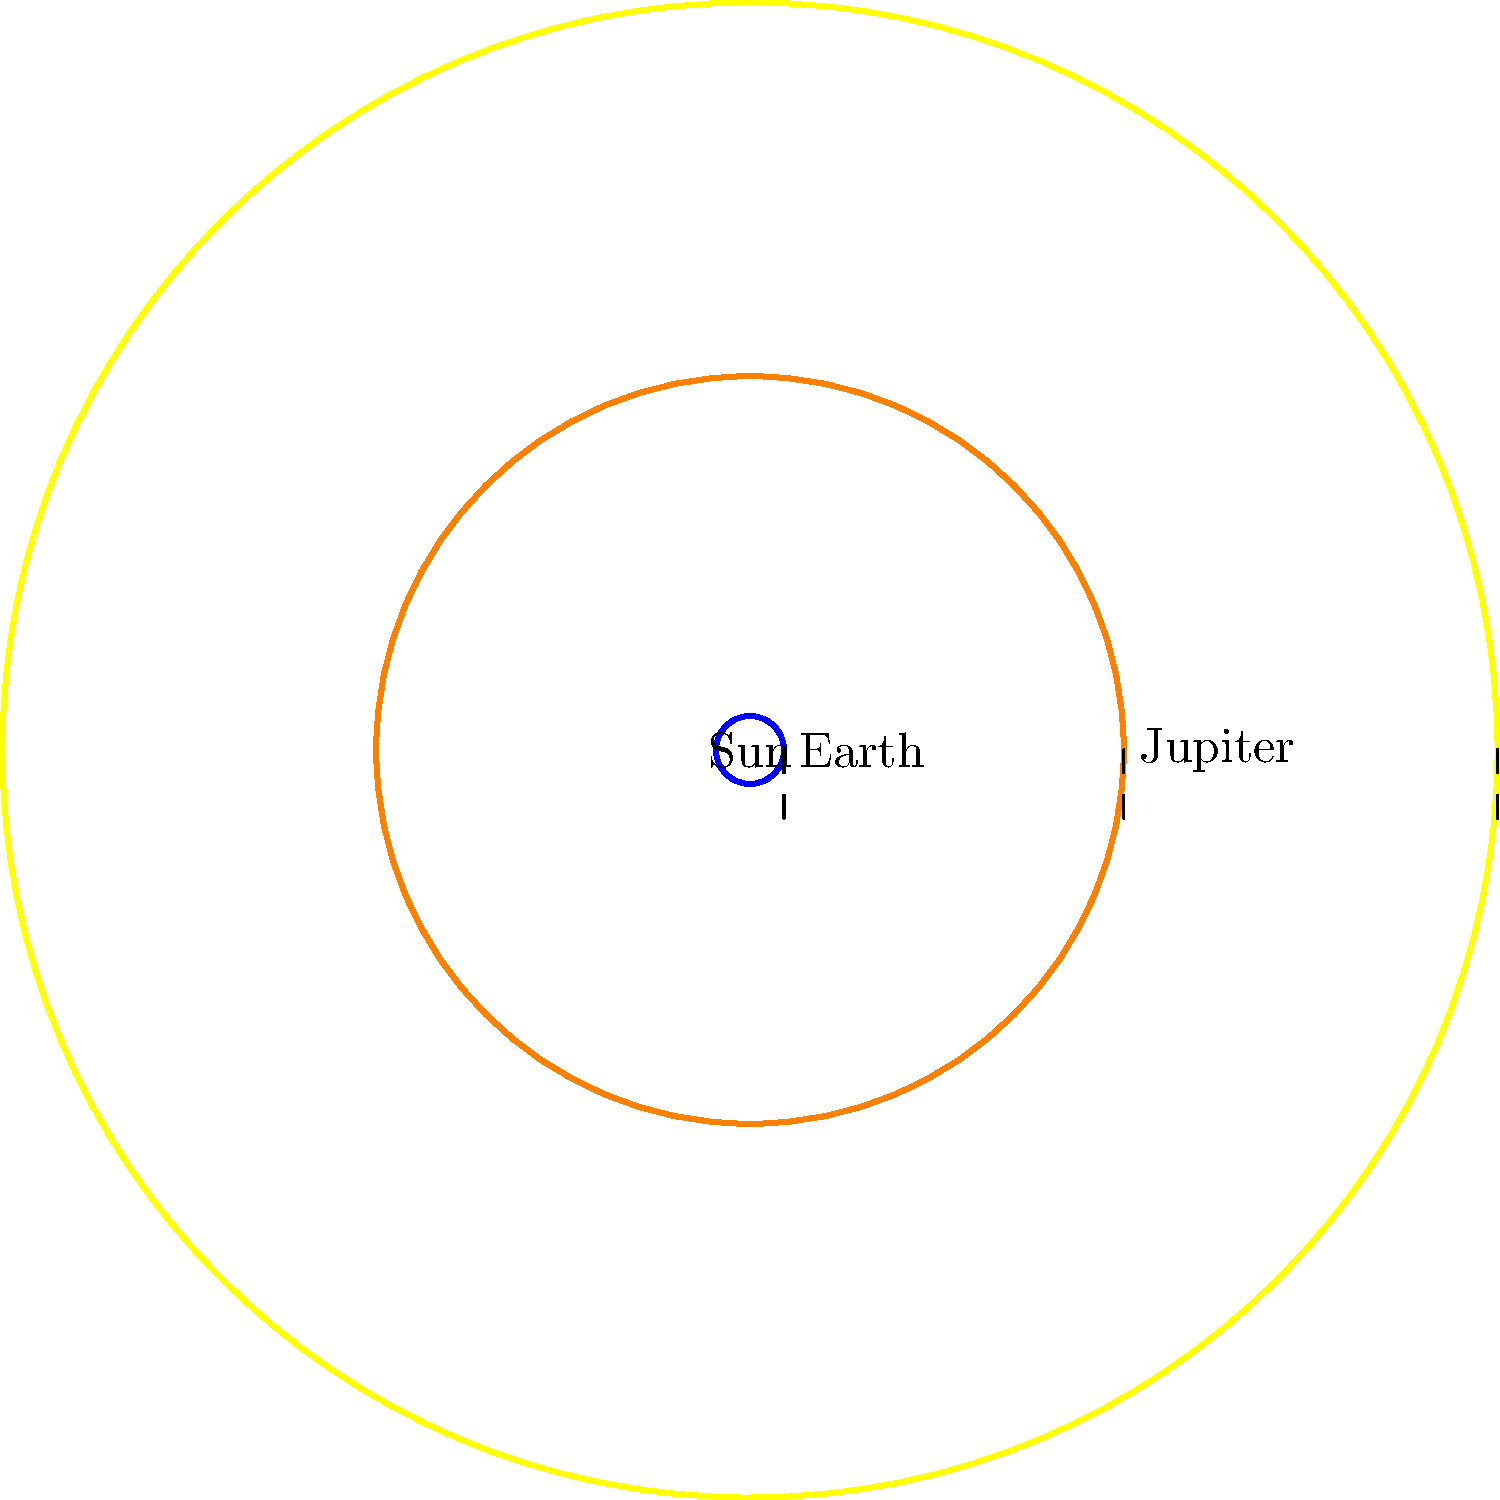As a homeowner who's dealt with insurance claims, you know the importance of accurate measurements. In our solar system, precise measurements are crucial too. Based on the diagram, which shows the relative sizes of the Sun, Jupiter, and Earth (not to scale), approximately how many Earths could fit inside Jupiter? To determine how many Earths could fit inside Jupiter, we need to compare their volumes. Since we're dealing with spheres, we can use the formula for the volume of a sphere: $V = \frac{4}{3}\pi r^3$, where $r$ is the radius.

Step 1: Measure the radii in the diagram
Earth's radius: 0.5 units
Jupiter's radius: 5.5 units

Step 2: Calculate the ratio of the radii
Jupiter's radius / Earth's radius = 5.5 / 0.5 = 11

Step 3: Calculate the volume ratio
(Jupiter's volume) / (Earth's volume) = $(11)^3 = 1331$

This means that approximately 1,331 Earths could fit inside Jupiter.

Note: The actual value is closer to 1,321, but our estimate is quite close given the simplified diagram.
Answer: Approximately 1,331 Earths 